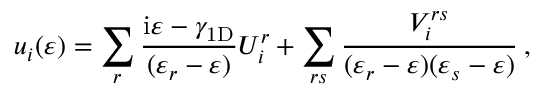<formula> <loc_0><loc_0><loc_500><loc_500>u _ { i } ( \varepsilon ) = \sum _ { r } \frac { i \varepsilon - \gamma _ { 1 D } } { ( \varepsilon _ { r } - \varepsilon ) } U _ { i } ^ { r } + \sum _ { r s } \frac { V _ { i } ^ { r s } } { ( \varepsilon _ { r } - \varepsilon ) ( \varepsilon _ { s } - \varepsilon ) } \, ,</formula> 